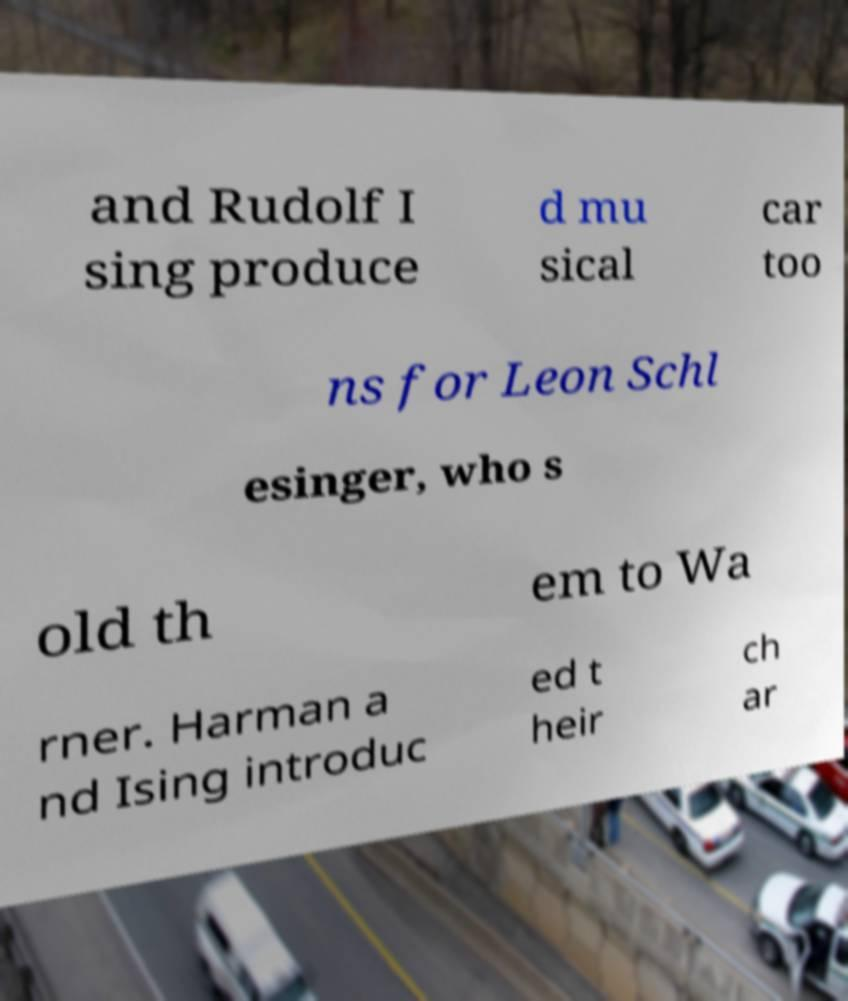I need the written content from this picture converted into text. Can you do that? and Rudolf I sing produce d mu sical car too ns for Leon Schl esinger, who s old th em to Wa rner. Harman a nd Ising introduc ed t heir ch ar 